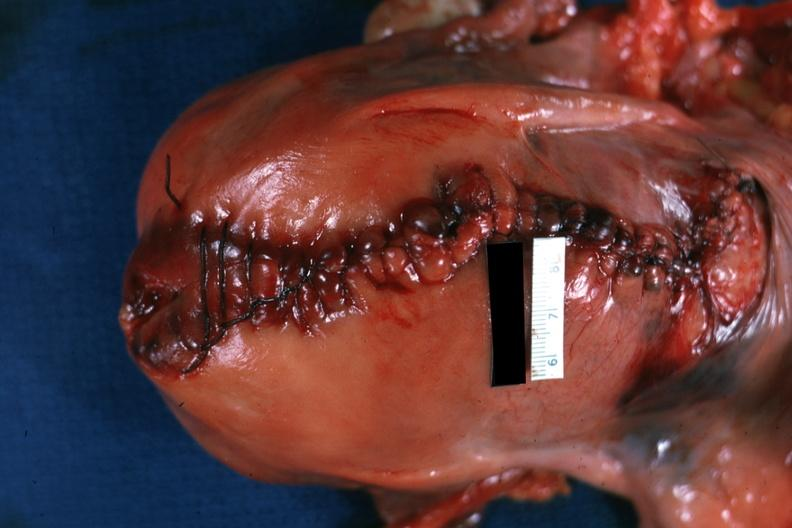s female reproductive present?
Answer the question using a single word or phrase. Yes 